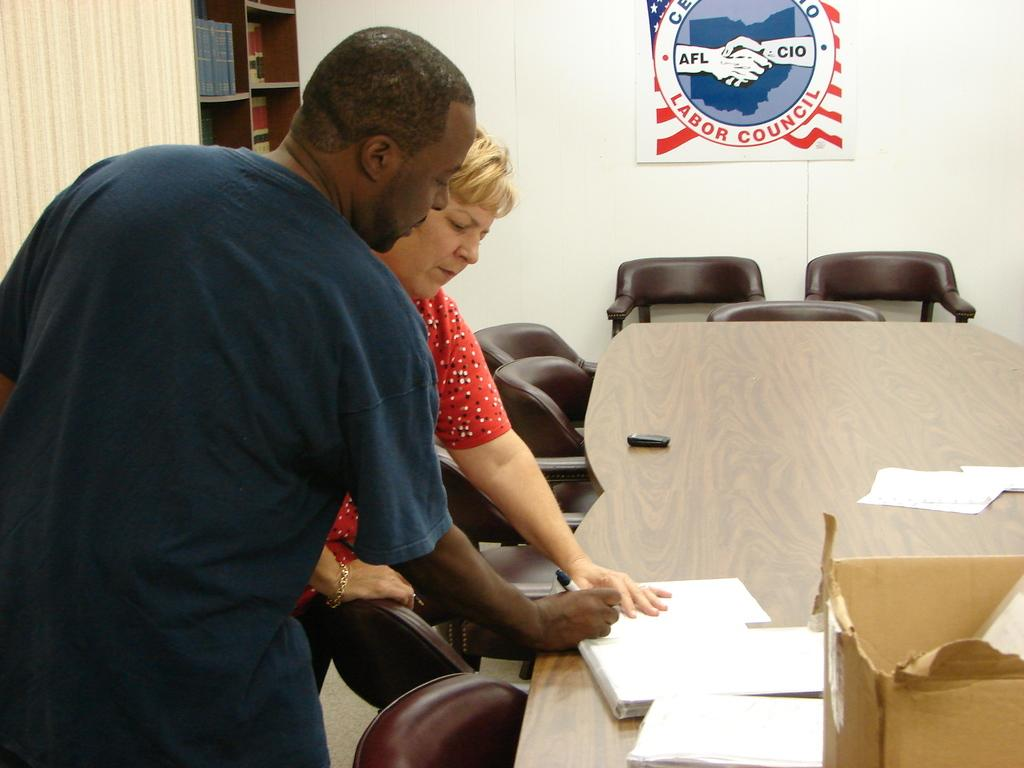How many people are present in the image? There are two people, a man and a woman, present in the image. What are the man and woman doing in the image? The man and woman are standing in the image. What furniture can be seen in the image? There are chairs and a table in the image. What items are on the table? There are papers and a box on the table. Can you see the man and woman kissing in the image? There is no indication of a kiss between the man and woman in the image. 